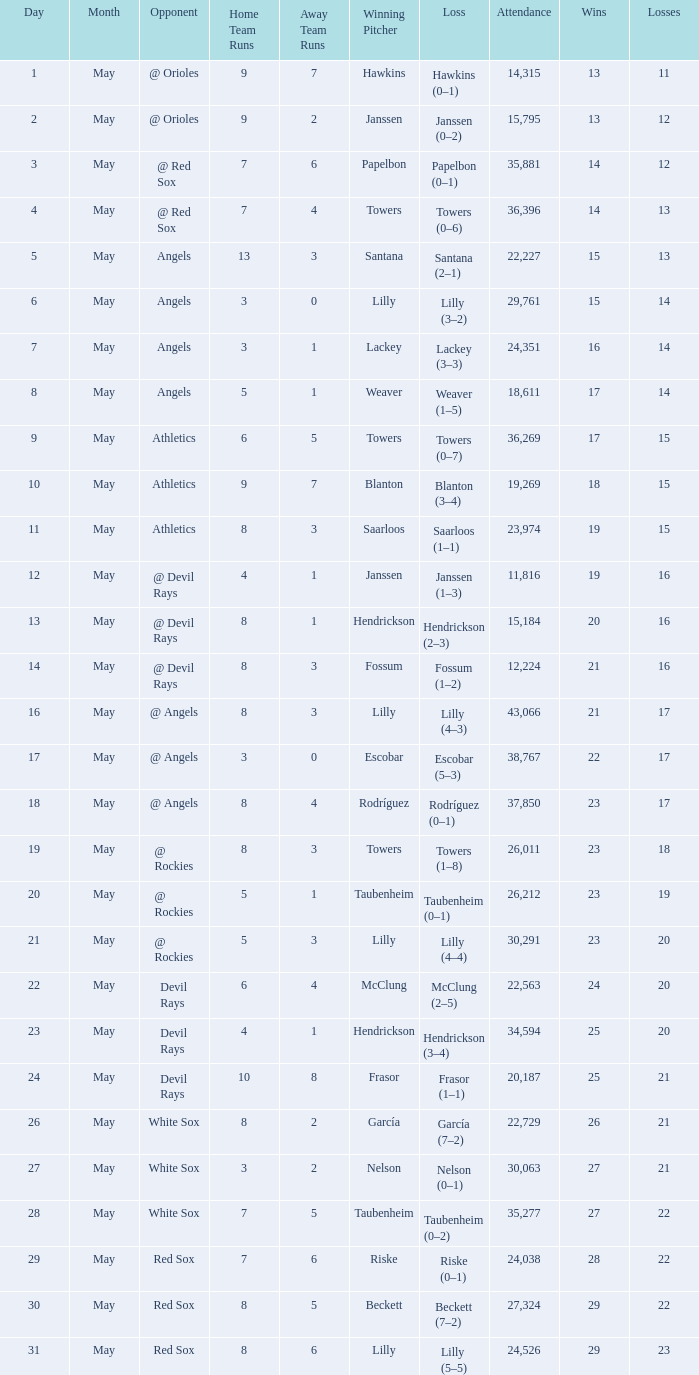What was the average attendance for games with a loss of papelbon (0–1)? 35881.0. 